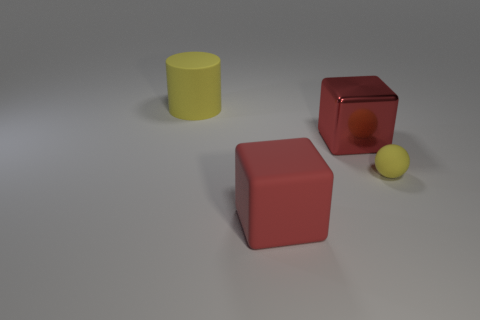How many balls are to the left of the big shiny cube?
Your response must be concise. 0. Do the rubber object that is in front of the matte sphere and the tiny yellow sphere have the same size?
Provide a short and direct response. No. The large shiny object that is the same shape as the large red rubber thing is what color?
Ensure brevity in your answer.  Red. Is there anything else that is the same shape as the small rubber object?
Provide a short and direct response. No. The red thing behind the tiny yellow ball has what shape?
Offer a terse response. Cube. What number of tiny objects have the same shape as the large yellow rubber thing?
Keep it short and to the point. 0. Is the color of the large rubber thing to the right of the big matte cylinder the same as the big thing behind the red shiny thing?
Offer a terse response. No. What number of objects are either large yellow shiny balls or big cubes?
Offer a terse response. 2. How many spheres have the same material as the cylinder?
Your response must be concise. 1. Are there fewer big green cylinders than tiny yellow things?
Provide a succinct answer. Yes. 